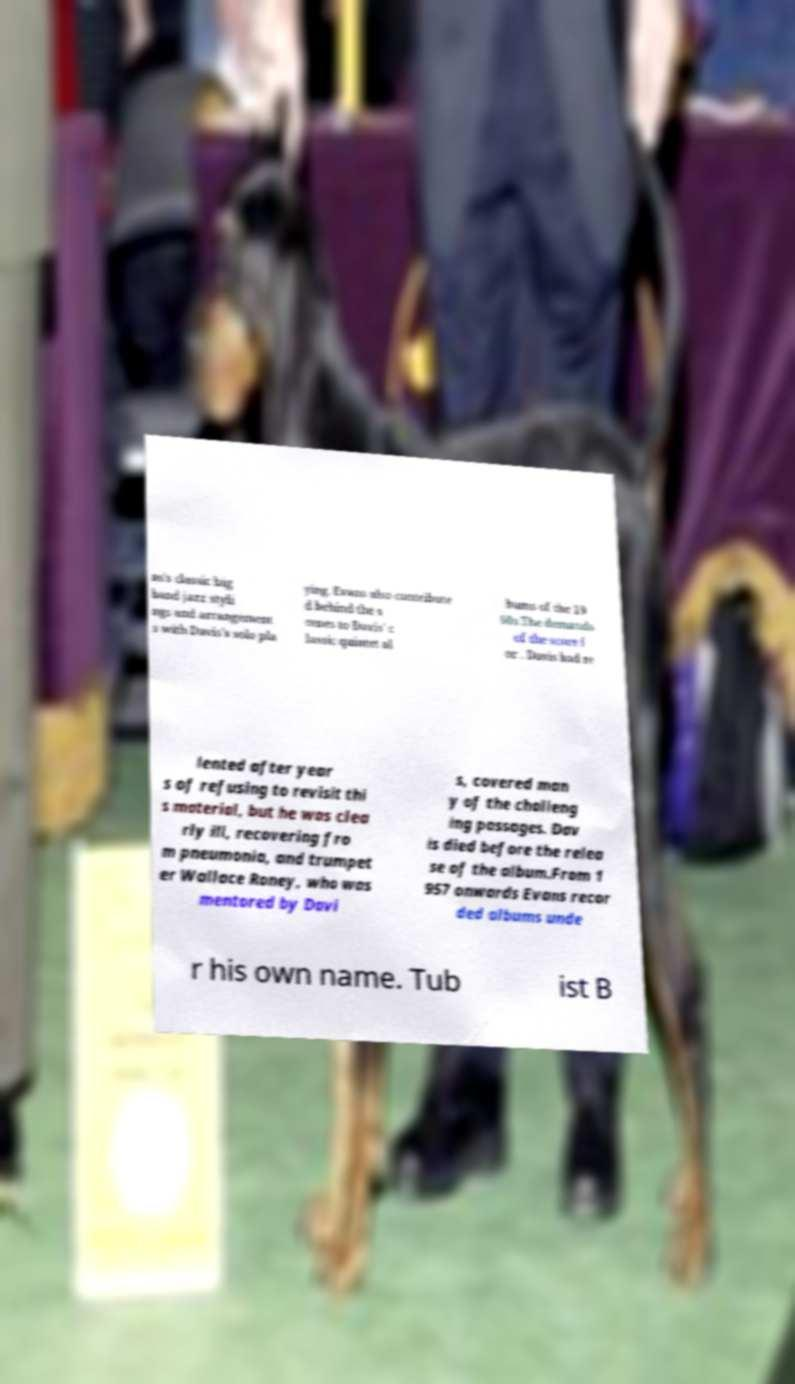For documentation purposes, I need the text within this image transcribed. Could you provide that? ns's classic big band jazz styli ngs and arrangement s with Davis's solo pla ying. Evans also contribute d behind the s cenes to Davis' c lassic quintet al bums of the 19 60s.The demands of the score f or . Davis had re lented after year s of refusing to revisit thi s material, but he was clea rly ill, recovering fro m pneumonia, and trumpet er Wallace Roney, who was mentored by Davi s, covered man y of the challeng ing passages. Dav is died before the relea se of the album.From 1 957 onwards Evans recor ded albums unde r his own name. Tub ist B 